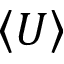Convert formula to latex. <formula><loc_0><loc_0><loc_500><loc_500>\left < U \right ></formula> 